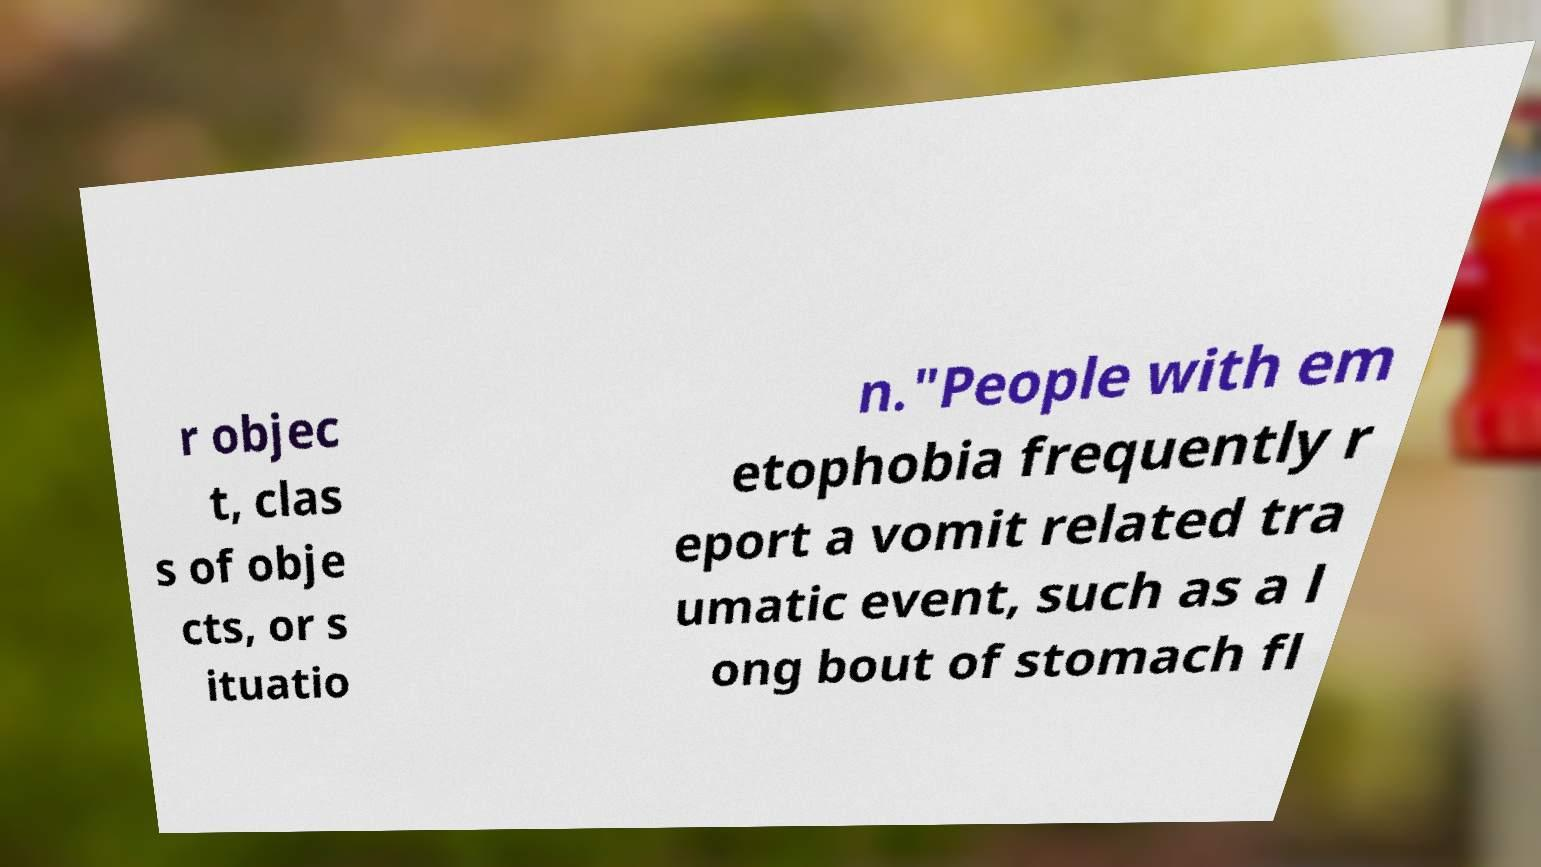Please read and relay the text visible in this image. What does it say? r objec t, clas s of obje cts, or s ituatio n."People with em etophobia frequently r eport a vomit related tra umatic event, such as a l ong bout of stomach fl 